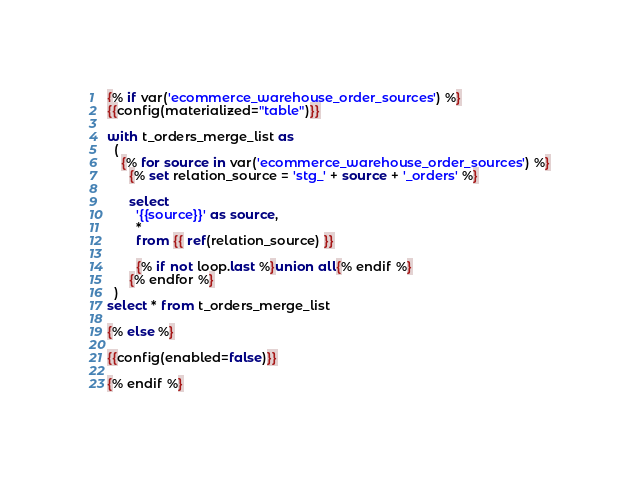<code> <loc_0><loc_0><loc_500><loc_500><_SQL_>{% if var('ecommerce_warehouse_order_sources') %}
{{config(materialized="table")}}

with t_orders_merge_list as
  (
    {% for source in var('ecommerce_warehouse_order_sources') %}
      {% set relation_source = 'stg_' + source + '_orders' %}

      select
        '{{source}}' as source,
        *
        from {{ ref(relation_source) }}

        {% if not loop.last %}union all{% endif %}
      {% endfor %}
  )
select * from t_orders_merge_list

{% else %}

{{config(enabled=false)}}

{% endif %}
</code> 